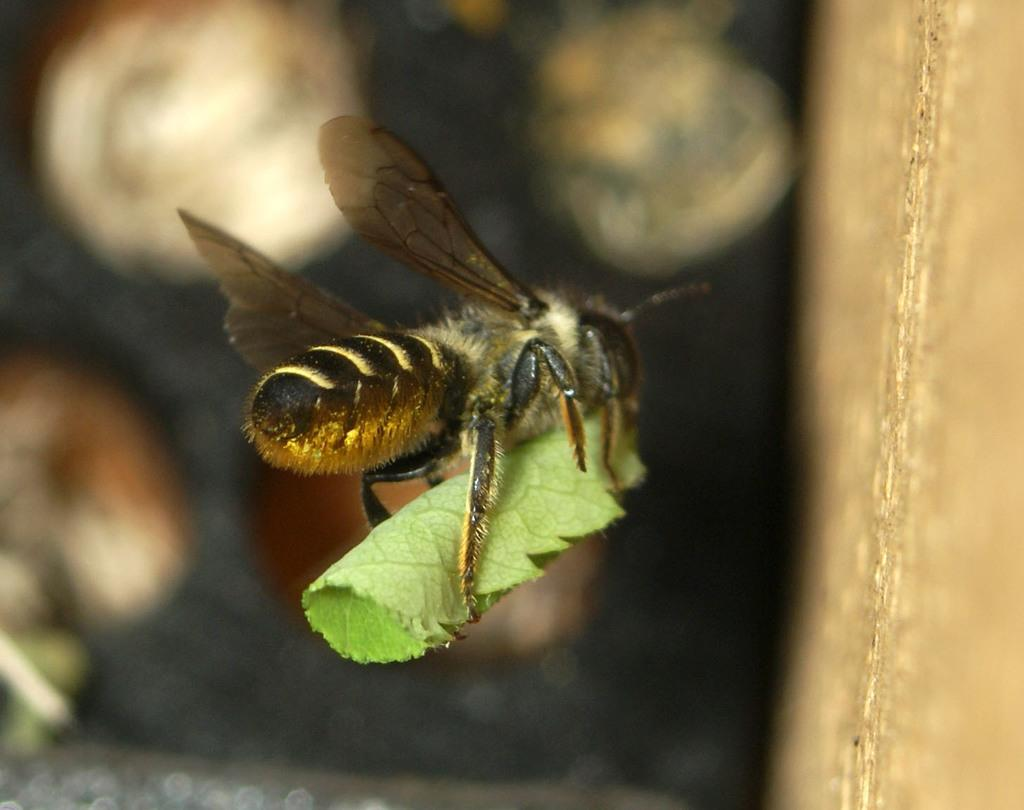What is the main subject of the image? The main subject of the image is a honey bee on a leaf. Can you describe the object that is truncated towards the right side of the image? Unfortunately, we cannot provide a detailed description of the truncated object as it is not fully visible in the image. How would you describe the background of the image? The background of the image is blurred. What type of holiday is the honey bee celebrating in the image? There is no indication of a holiday in the image, as it primarily features a honey bee on a leaf. What color is the orange fruit in the image? There is no orange fruit present in the image. 